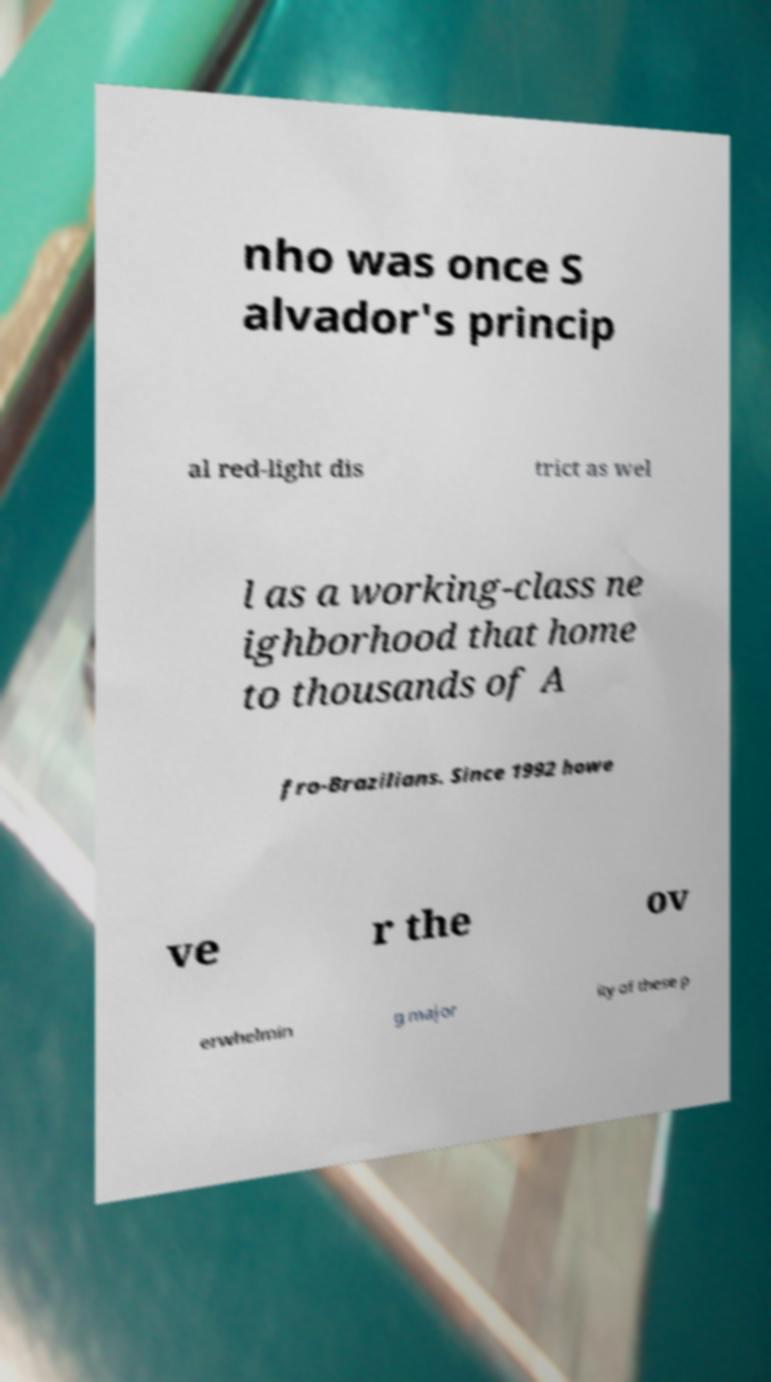Can you read and provide the text displayed in the image?This photo seems to have some interesting text. Can you extract and type it out for me? nho was once S alvador's princip al red-light dis trict as wel l as a working-class ne ighborhood that home to thousands of A fro-Brazilians. Since 1992 howe ve r the ov erwhelmin g major ity of these p 